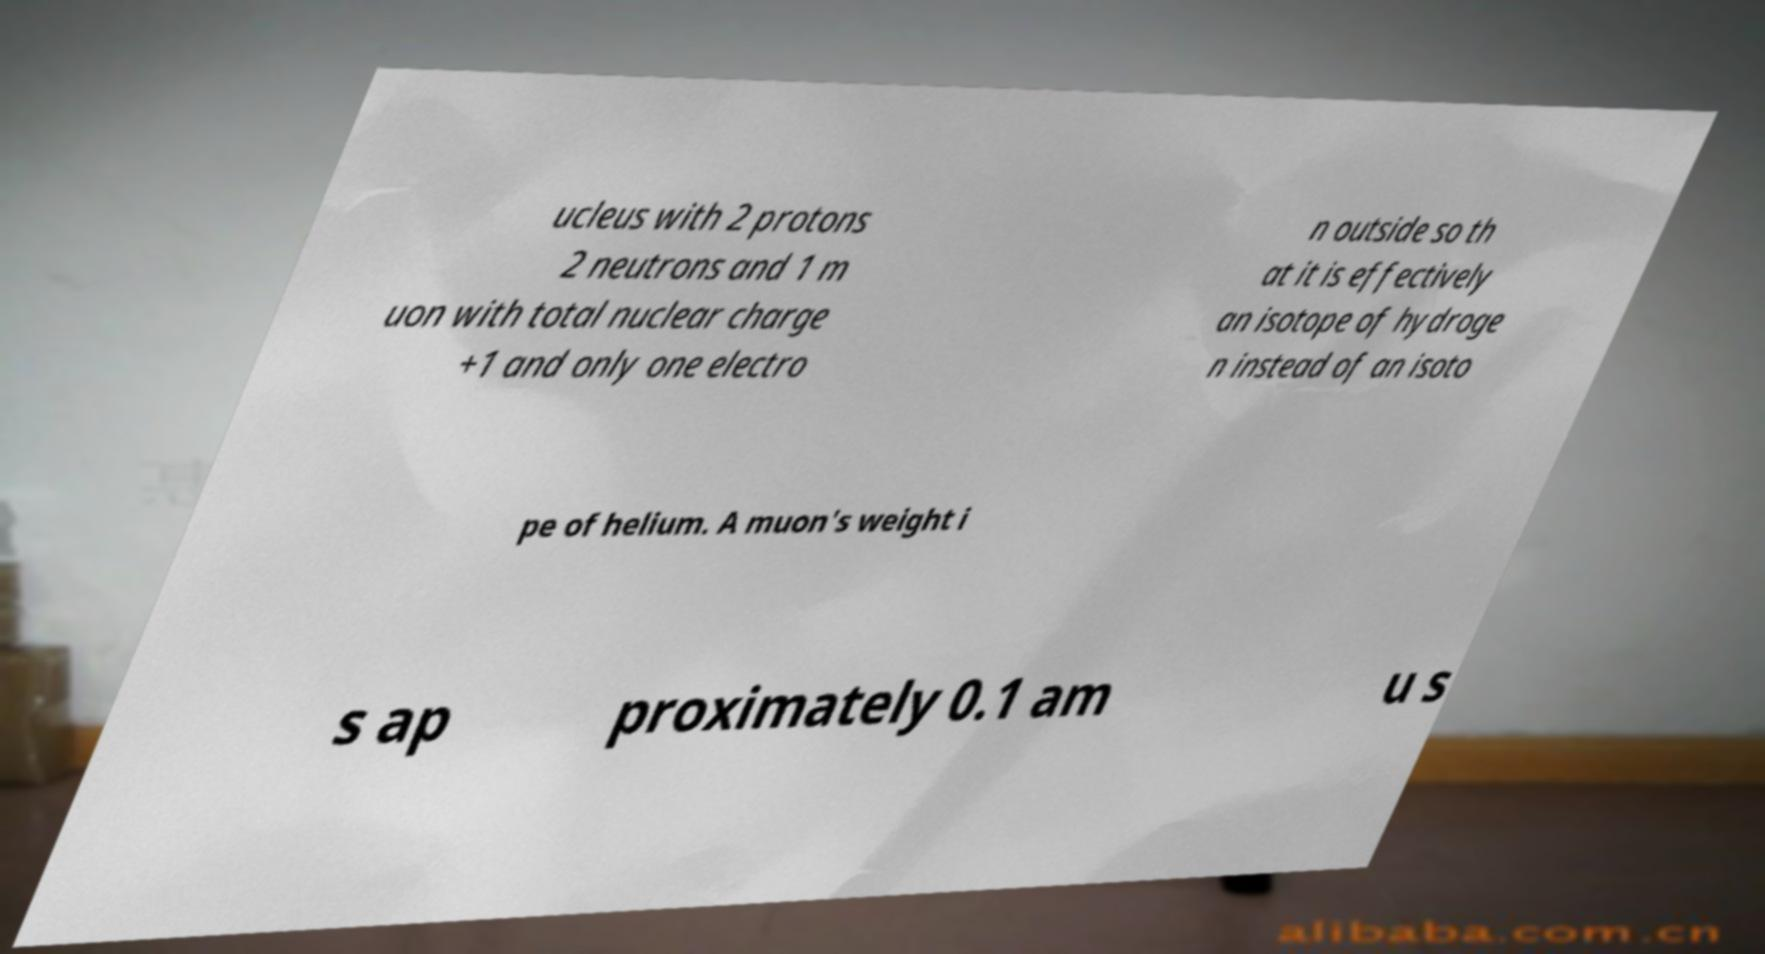Please identify and transcribe the text found in this image. ucleus with 2 protons 2 neutrons and 1 m uon with total nuclear charge +1 and only one electro n outside so th at it is effectively an isotope of hydroge n instead of an isoto pe of helium. A muon's weight i s ap proximately 0.1 am u s 